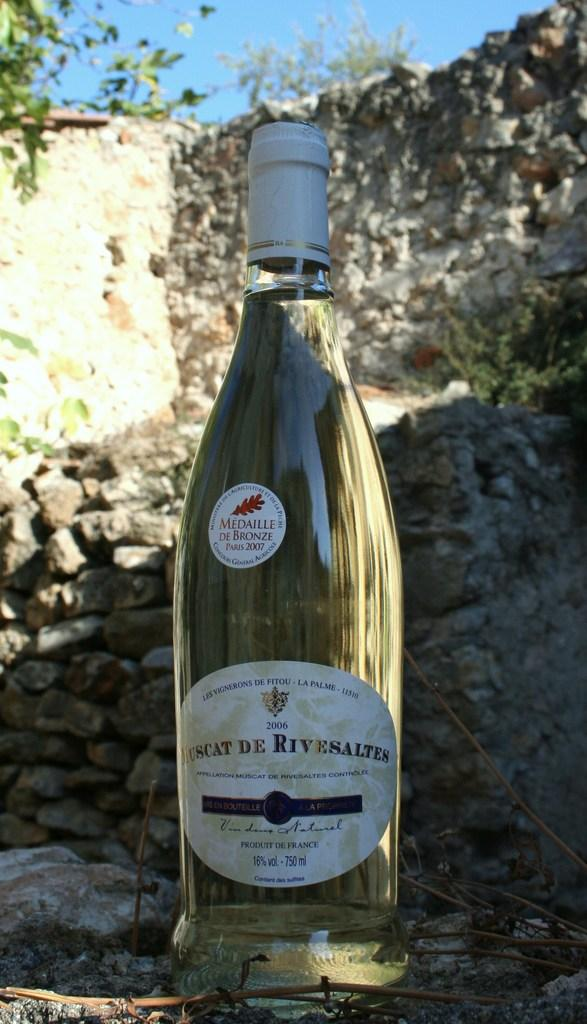<image>
Create a compact narrative representing the image presented. the word medaille is on a wine bottle 